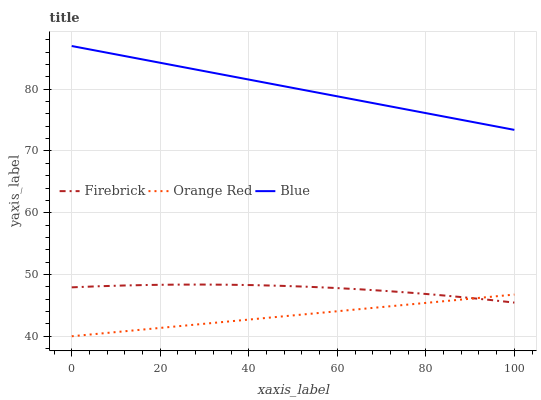Does Orange Red have the minimum area under the curve?
Answer yes or no. Yes. Does Blue have the maximum area under the curve?
Answer yes or no. Yes. Does Firebrick have the minimum area under the curve?
Answer yes or no. No. Does Firebrick have the maximum area under the curve?
Answer yes or no. No. Is Blue the smoothest?
Answer yes or no. Yes. Is Firebrick the roughest?
Answer yes or no. Yes. Is Orange Red the smoothest?
Answer yes or no. No. Is Orange Red the roughest?
Answer yes or no. No. Does Firebrick have the lowest value?
Answer yes or no. No. Does Blue have the highest value?
Answer yes or no. Yes. Does Firebrick have the highest value?
Answer yes or no. No. Is Orange Red less than Blue?
Answer yes or no. Yes. Is Blue greater than Orange Red?
Answer yes or no. Yes. Does Orange Red intersect Firebrick?
Answer yes or no. Yes. Is Orange Red less than Firebrick?
Answer yes or no. No. Is Orange Red greater than Firebrick?
Answer yes or no. No. Does Orange Red intersect Blue?
Answer yes or no. No. 